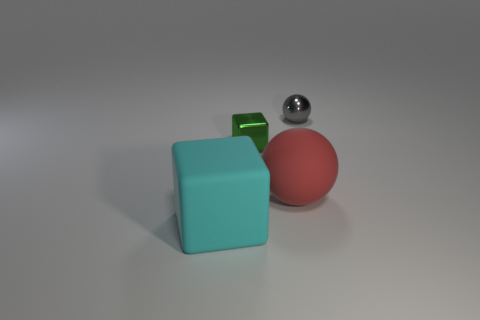Describe the objects' arrangement in the image. In the image, we see three geometric objects arranged from left to right in descending order of size with a teal cube, a red sphere, and a small green cube. 